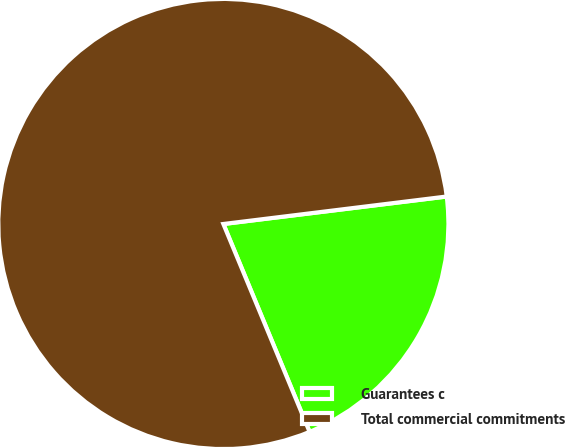<chart> <loc_0><loc_0><loc_500><loc_500><pie_chart><fcel>Guarantees c<fcel>Total commercial commitments<nl><fcel>20.69%<fcel>79.31%<nl></chart> 